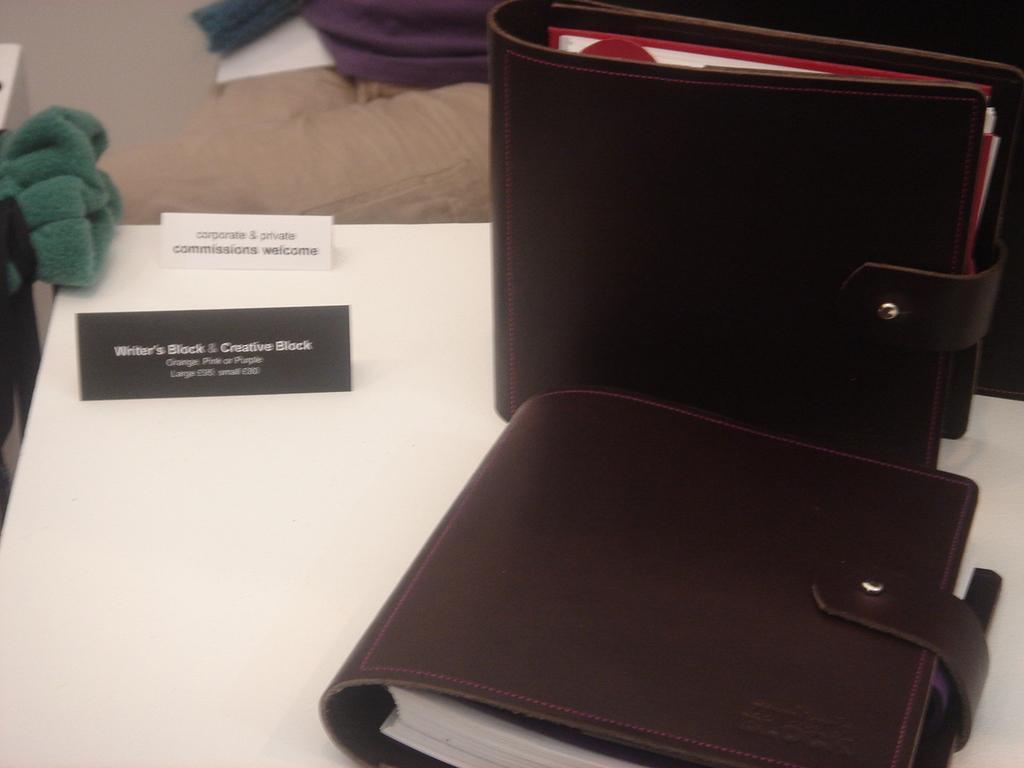How would you summarize this image in a sentence or two? In the picture we can see a white color desk on it, we can see two values which are brown in color and besides, we can see some cloth which is green in color and in the background we can see a wall. 